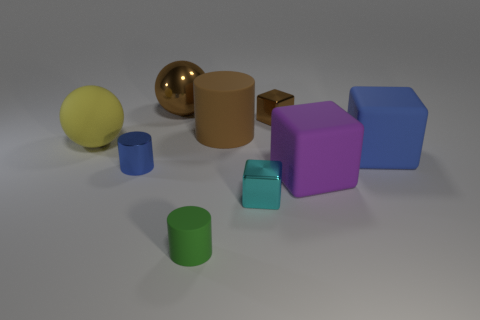Do the cylinder that is in front of the purple thing and the large brown metallic thing have the same size?
Provide a succinct answer. No. There is a green matte cylinder; how many matte cylinders are right of it?
Make the answer very short. 1. Is the number of yellow objects that are behind the small brown shiny object less than the number of tiny cyan metallic things that are to the left of the tiny blue metal cylinder?
Your answer should be compact. No. What number of purple things are there?
Offer a terse response. 1. What color is the large ball that is left of the blue shiny cylinder?
Offer a very short reply. Yellow. What size is the yellow ball?
Your answer should be compact. Large. There is a large metallic object; is its color the same as the small object that is left of the green object?
Provide a short and direct response. No. There is a ball to the right of the small metal object to the left of the brown ball; what is its color?
Your answer should be very brief. Brown. Is there anything else that is the same size as the green rubber cylinder?
Provide a short and direct response. Yes. Is the shape of the metal object in front of the large purple rubber thing the same as  the green rubber thing?
Offer a terse response. No. 